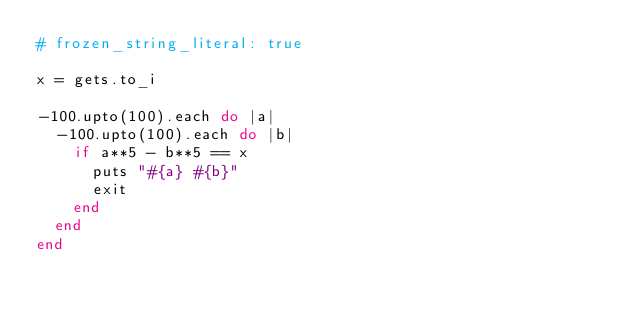Convert code to text. <code><loc_0><loc_0><loc_500><loc_500><_Ruby_># frozen_string_literal: true

x = gets.to_i

-100.upto(100).each do |a|
  -100.upto(100).each do |b|
    if a**5 - b**5 == x
      puts "#{a} #{b}"
      exit
    end
  end
end
</code> 